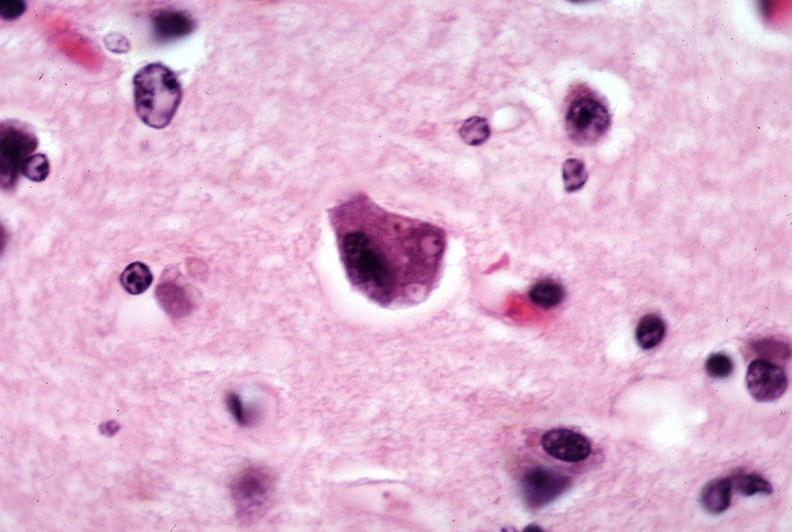s gout present?
Answer the question using a single word or phrase. No 